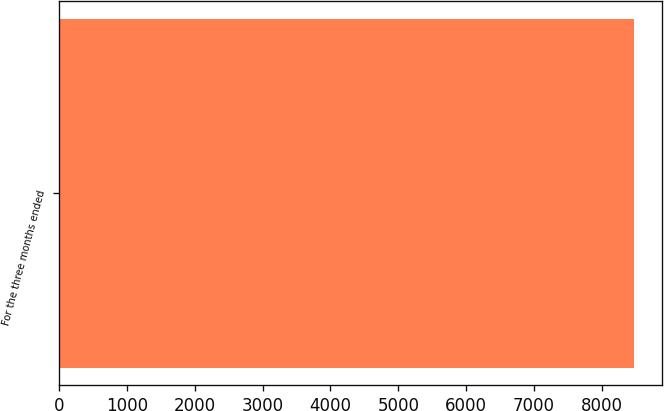Convert chart to OTSL. <chart><loc_0><loc_0><loc_500><loc_500><bar_chart><fcel>For the three months ended<nl><fcel>8471<nl></chart> 